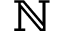Convert formula to latex. <formula><loc_0><loc_0><loc_500><loc_500>{ \mathbb { N } }</formula> 